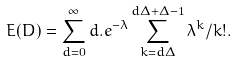Convert formula to latex. <formula><loc_0><loc_0><loc_500><loc_500>E ( D ) = \sum _ { d = 0 } ^ { \infty } d . e ^ { - \lambda } \sum _ { k = d \Delta } ^ { d \Delta + \Delta - 1 } \lambda ^ { k } / k ! .</formula> 